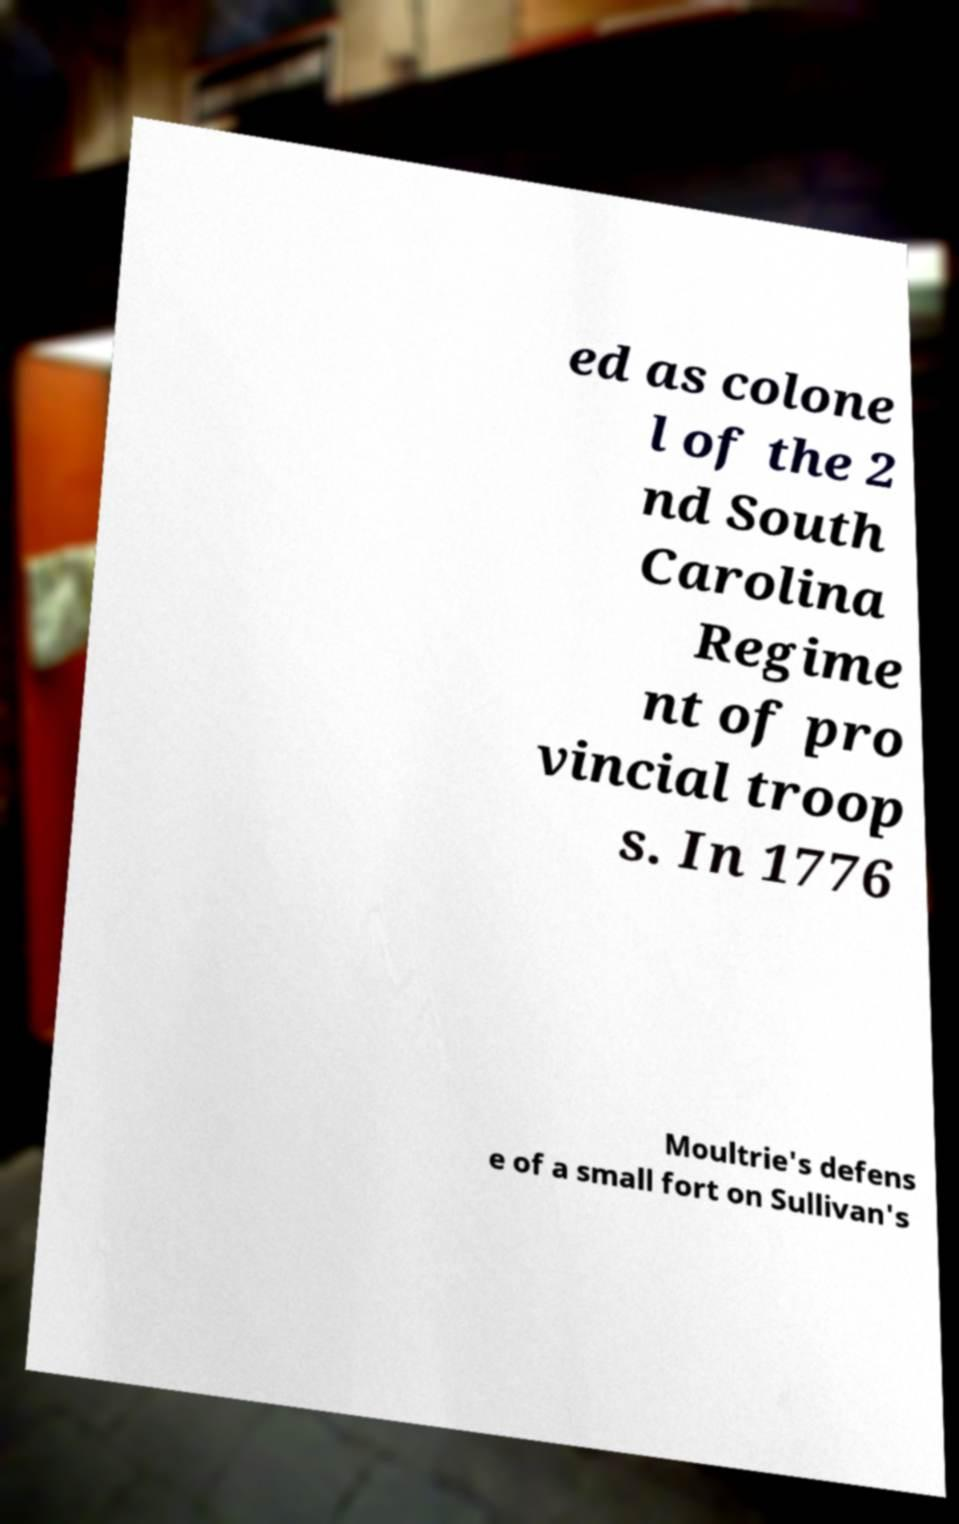Can you accurately transcribe the text from the provided image for me? ed as colone l of the 2 nd South Carolina Regime nt of pro vincial troop s. In 1776 Moultrie's defens e of a small fort on Sullivan's 